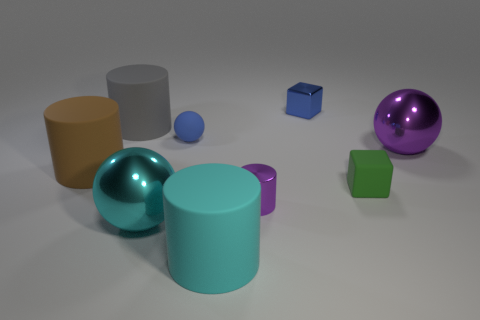There is a cyan cylinder that is the same size as the gray thing; what material is it? Based on the image, the cyan cylinder appears to have a matte surface similar to painted plastic or ceramic, but without more information, I can't determine the exact material. Objects in images like these often represent common materials such as plastic, metal, or ceramic, each with different properties like weight, texture, and reflection. 